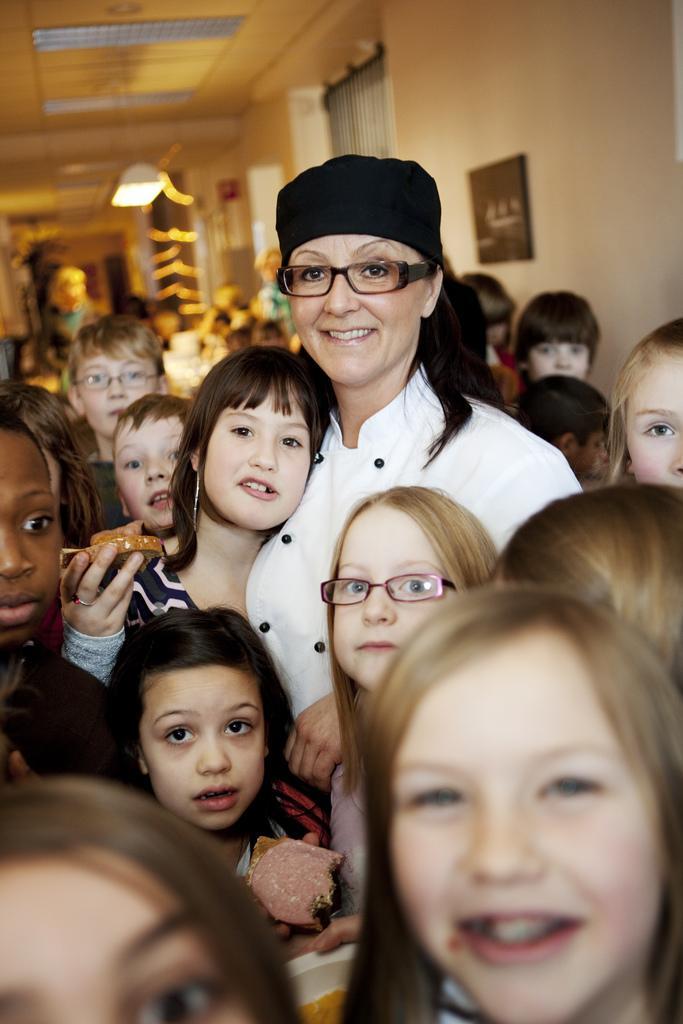Please provide a concise description of this image. Here we can see group of people posing to a camera. In the background we can see a light, frame, and wall. 